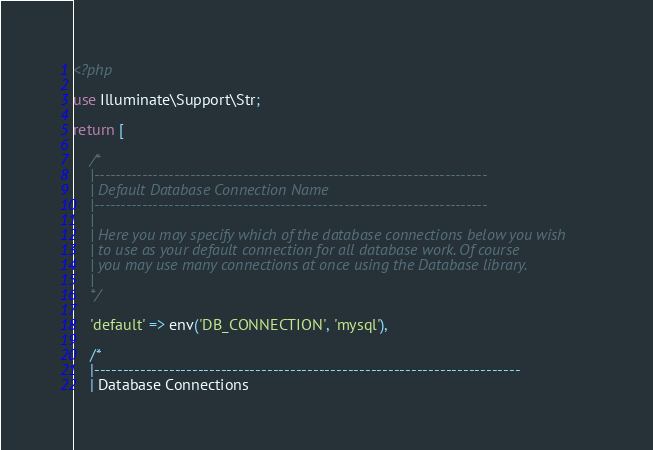Convert code to text. <code><loc_0><loc_0><loc_500><loc_500><_PHP_><?php

use Illuminate\Support\Str;

return [

    /*
    |--------------------------------------------------------------------------
    | Default Database Connection Name
    |--------------------------------------------------------------------------
    |
    | Here you may specify which of the database connections below you wish
    | to use as your default connection for all database work. Of course
    | you may use many connections at once using the Database library.
    |
    */

    'default' => env('DB_CONNECTION', 'mysql'),

    /*
    |--------------------------------------------------------------------------
    | Database Connections</code> 